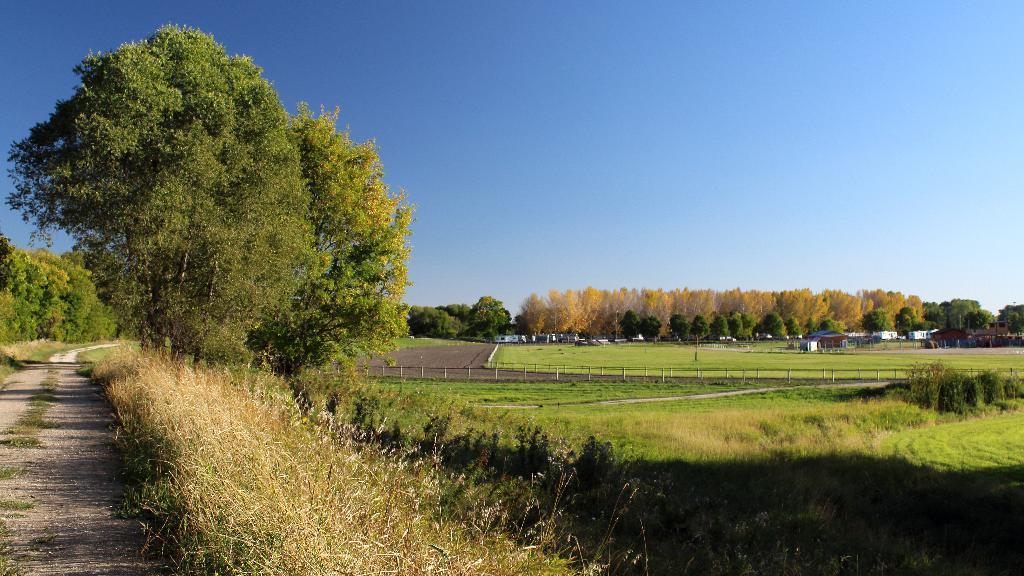In one or two sentences, can you explain what this image depicts? The picture is taken along the countryside. In the foreground of the picture there are fields, grass and path. In the center of the picture there are trees, fencing, fields. In the background there are trees and houses. Sky is sunny. 